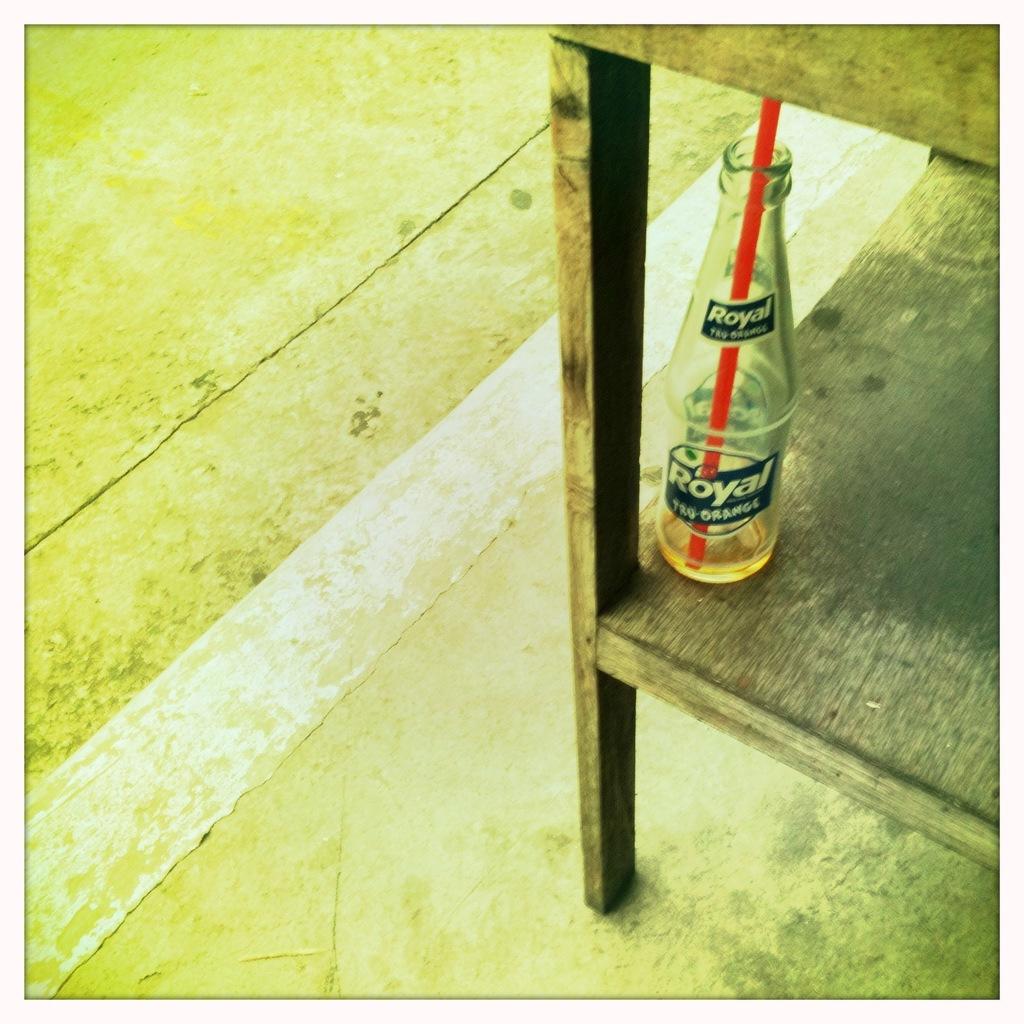What is the name of the drink?
Keep it short and to the point. Royal. 